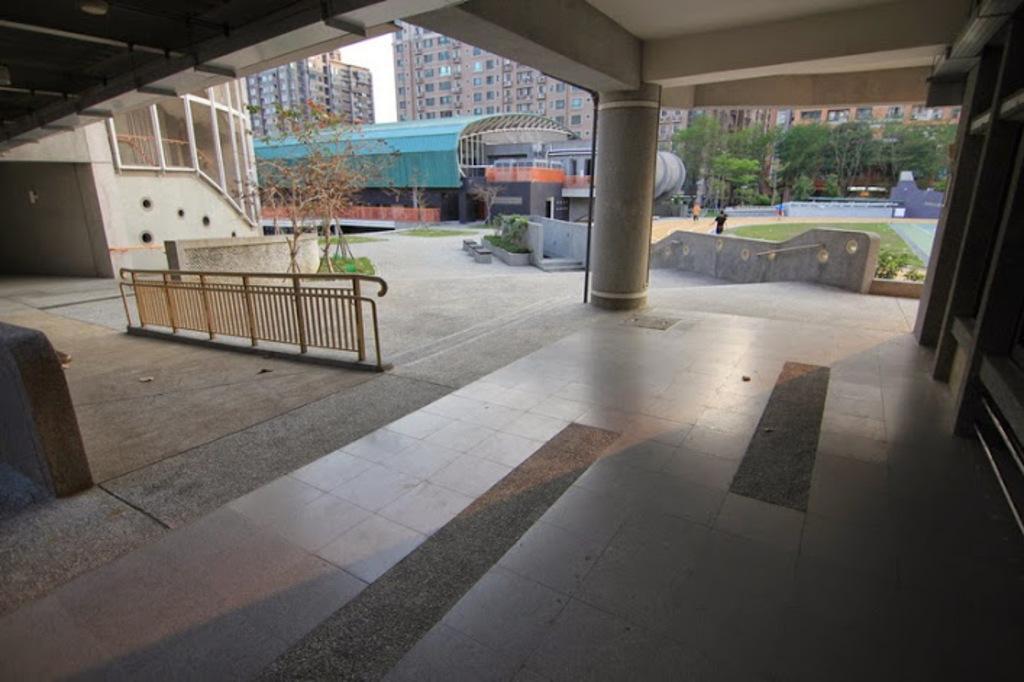Please provide a concise description of this image. In the picture we can see a house building with a roof outside with pillars and behind it, we can see some railing and behind it, we can see some plants and in the background, we can see some people walking on the path and trees and we can also see some buildings with a window and sky. 